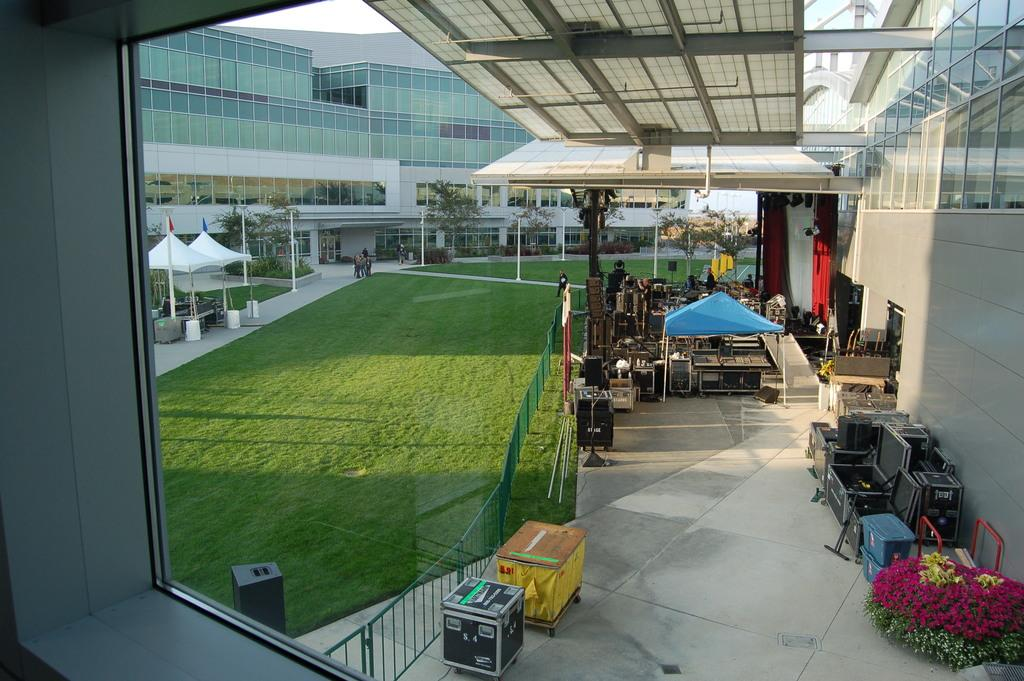What type of structures can be seen in the image? There are buildings in the image. What temporary shelters are present in the image? There are tents in the image. What objects are used for storage in the image? There are boxes in the image. What type of vegetation is present in the image? There are flower plants, trees, and grass in the image. What device is used for amplifying sound in the image? There is a speaker in the image. What type of furniture is present in the image? There are tables in the image. What type of textile is used for window treatment in the image? There are curtains in the image. What type of brake is visible in the image? There is no brake present in the image. 